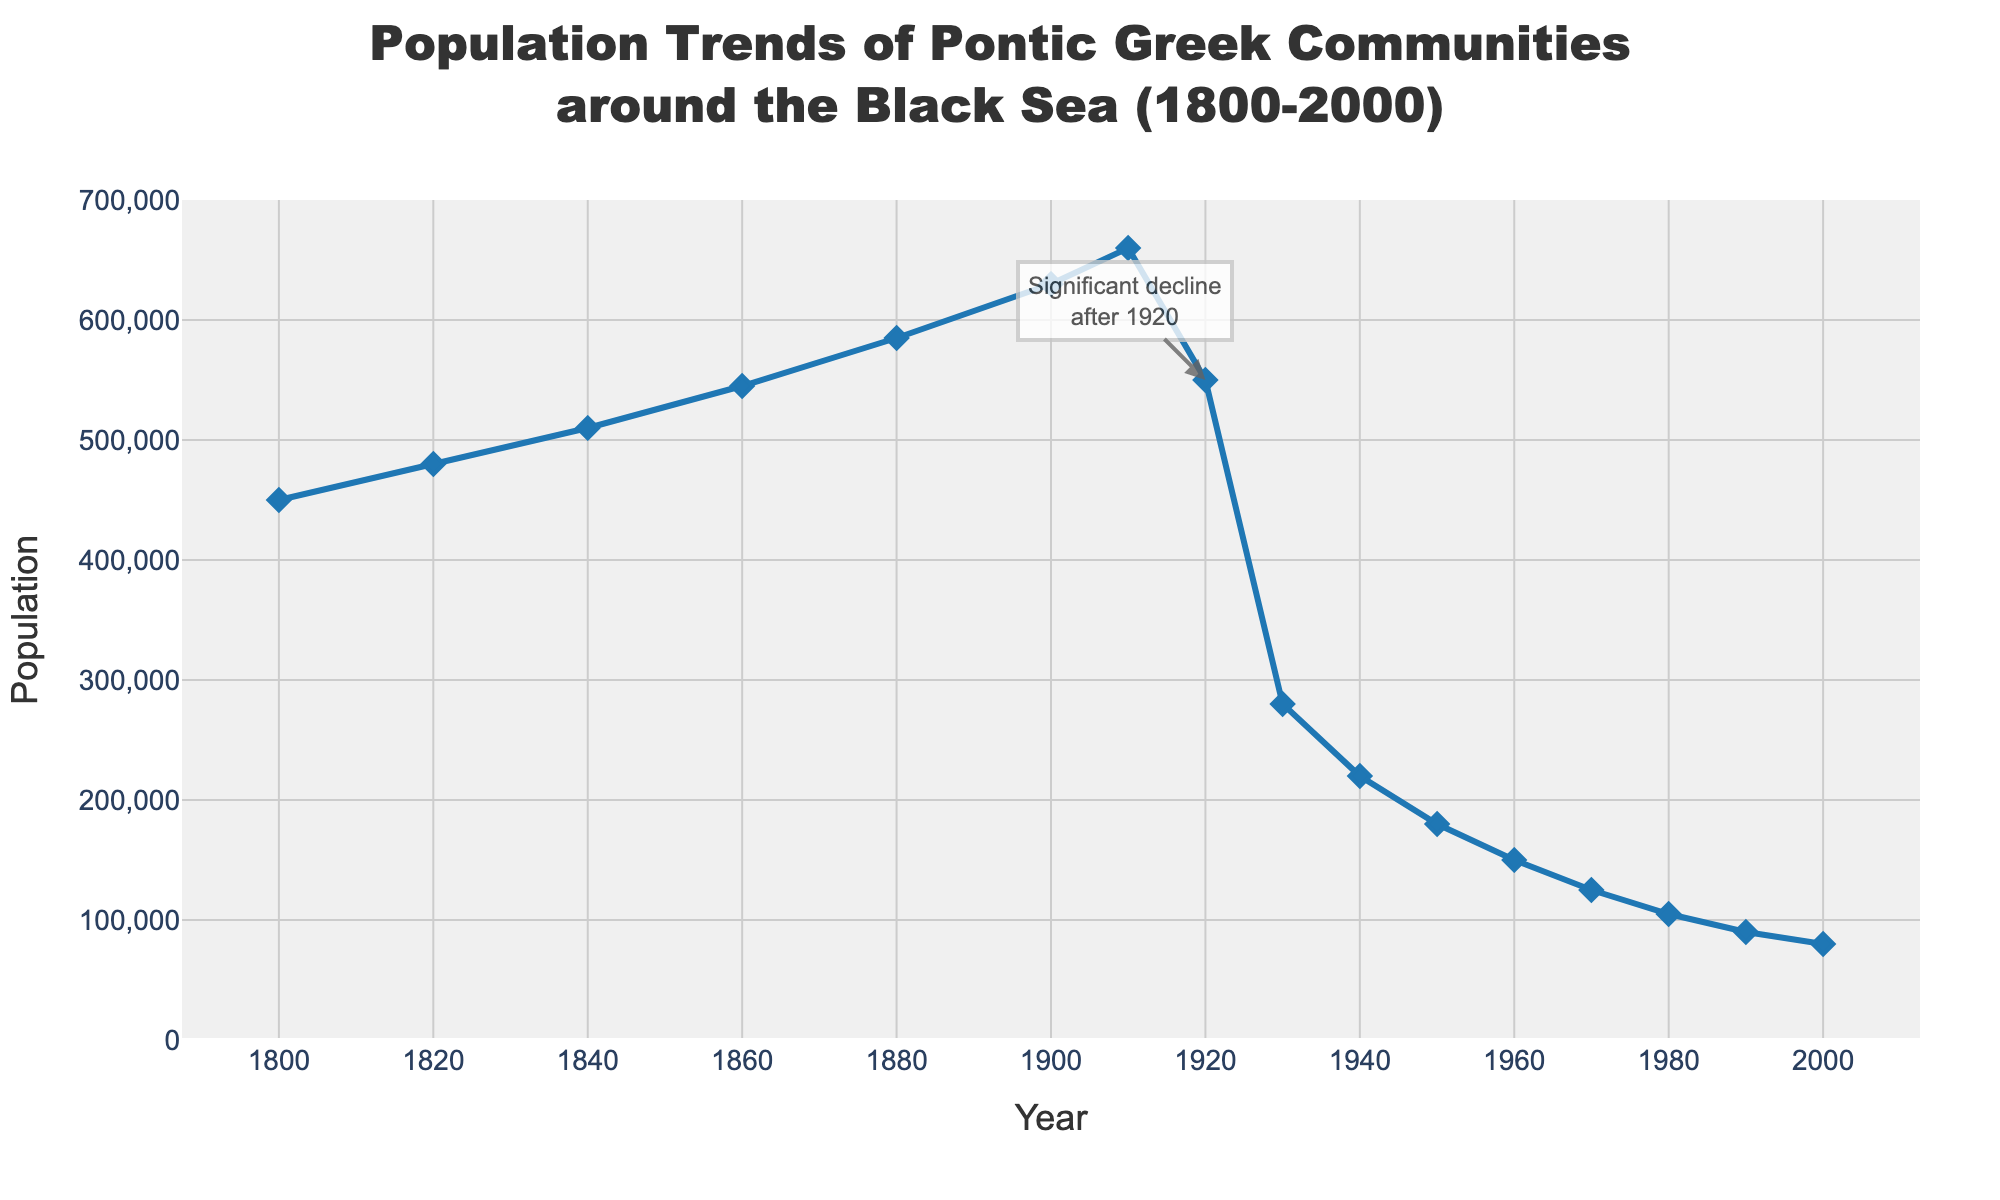How did the population change between 1910 and 1920? To find the population change between 1910 and 1920, subtract the population in 1920 from the population in 1910. The population in 1910 is 660,000 and in 1920 it is 550,000. Therefore, the population change is 660,000 - 550,000 = 110,000.
Answer: 110,000 In which year did the Pontic Greek population experience the largest decline? The largest decline can be observed by identifying the year with the steepest drop in population numbers. Between 1920 and 1930, the population decreased from 550,000 to 280,000, which is a decline of 270,000, the steepest decline in the given period.
Answer: 1930 What is the overall trend of the Pontic Greek population from 1800 to 2000? To determine the overall trend, observe the population at the starting and ending points in the given period. In 1800, the population was 450,000, and by 2000 it had decreased to 80,000. The trend shows a general decline.
Answer: Decline How does the population in 1920 compare to the population in 1900? To compare, look at the population values for these years. In 1900, the population was 630,000 and in 1920 it was 550,000. The population in 1920 is less than the population in 1900.
Answer: Less Calculate the average population of the Pontic Greeks from 1900 to 2000. To calculate the average, sum the population values from 1900 to 2000 and divide by the number of data points. The values are: 630,000 (1900), 660,000 (1910), 550,000 (1920), 280,000 (1930), 220,000 (1940), 180,000 (1950), 150,000 (1960), 125,000 (1970), 105,000 (1980), 90,000 (1990), and 80,000 (2000). The sum is 3,070,000, and there are 11 data points, so the average is 3,070,000 / 11 ≈ 279,091.
Answer: 279,091 What visual feature in the plot highlights the significant population decline after 1920? The plot includes an annotation marking the significant decline after 1920 with text and an arrow.
Answer: Annotation with text and arrow At which decade did the population drop to below 300,000? By examining the population values for each decade, it is clear that in 1930 the population dropped to 280,000, which is the first instance it falls below 300,000.
Answer: 1930 How many years did it take for the population to halve from 1900 levels? The population in 1900 was 630,000. To find when it halves to approximately 315,000, observe the closest population below this value. By 1930, the population had decreased to 280,000, taking 30 years from 1900.
Answer: 30 years 